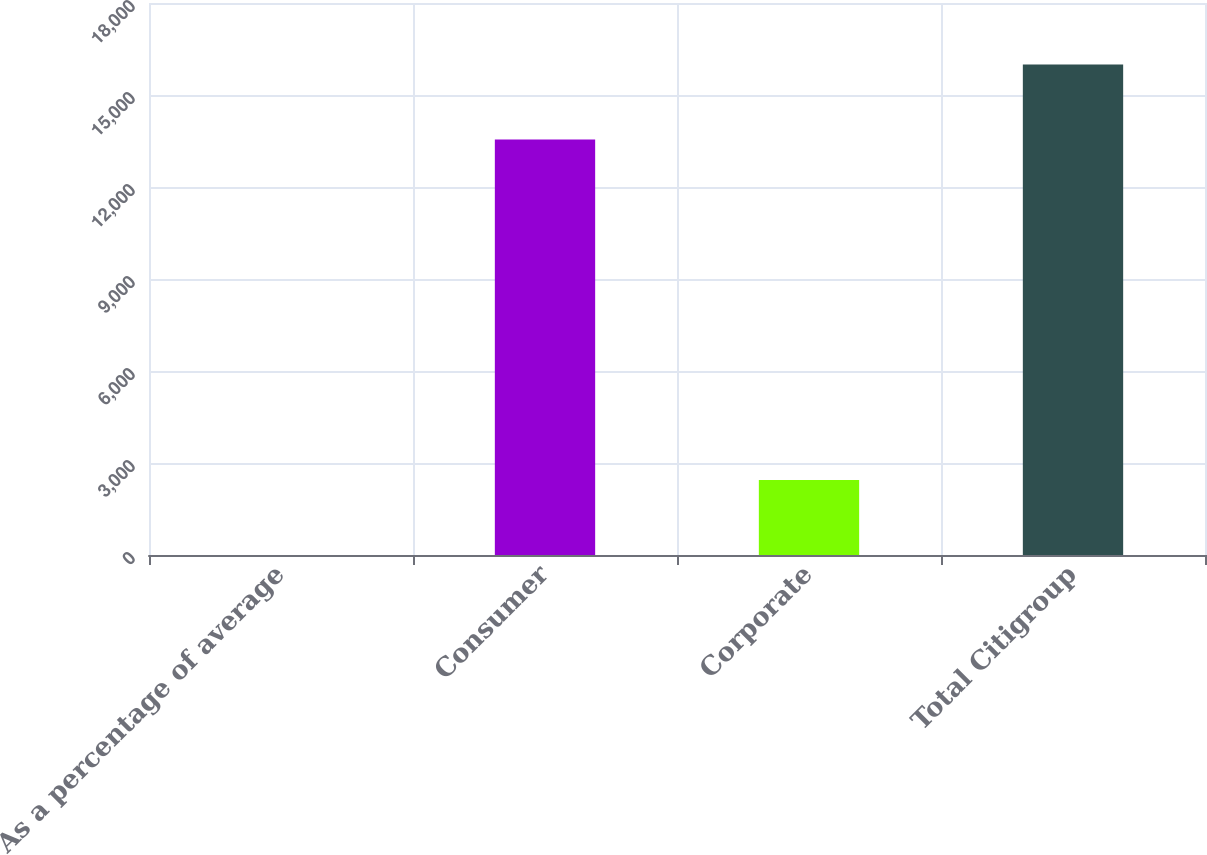Convert chart. <chart><loc_0><loc_0><loc_500><loc_500><bar_chart><fcel>As a percentage of average<fcel>Consumer<fcel>Corporate<fcel>Total Citigroup<nl><fcel>0.1<fcel>13547<fcel>2447<fcel>15994<nl></chart> 